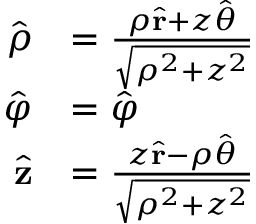Convert formula to latex. <formula><loc_0><loc_0><loc_500><loc_500>{ \begin{array} { r l } { { \hat { \rho } } } & { = { \frac { \rho { \hat { r } } + z { \hat { \theta } } } { \sqrt { \rho ^ { 2 } + z ^ { 2 } } } } } \\ { { \hat { \varphi } } } & { = { \hat { \varphi } } } \\ { { \hat { z } } } & { = { \frac { z { \hat { r } } - \rho { \hat { \theta } } } { \sqrt { \rho ^ { 2 } + z ^ { 2 } } } } } \end{array} }</formula> 